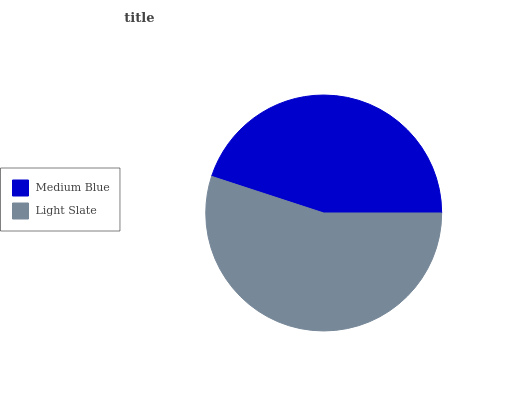Is Medium Blue the minimum?
Answer yes or no. Yes. Is Light Slate the maximum?
Answer yes or no. Yes. Is Light Slate the minimum?
Answer yes or no. No. Is Light Slate greater than Medium Blue?
Answer yes or no. Yes. Is Medium Blue less than Light Slate?
Answer yes or no. Yes. Is Medium Blue greater than Light Slate?
Answer yes or no. No. Is Light Slate less than Medium Blue?
Answer yes or no. No. Is Light Slate the high median?
Answer yes or no. Yes. Is Medium Blue the low median?
Answer yes or no. Yes. Is Medium Blue the high median?
Answer yes or no. No. Is Light Slate the low median?
Answer yes or no. No. 